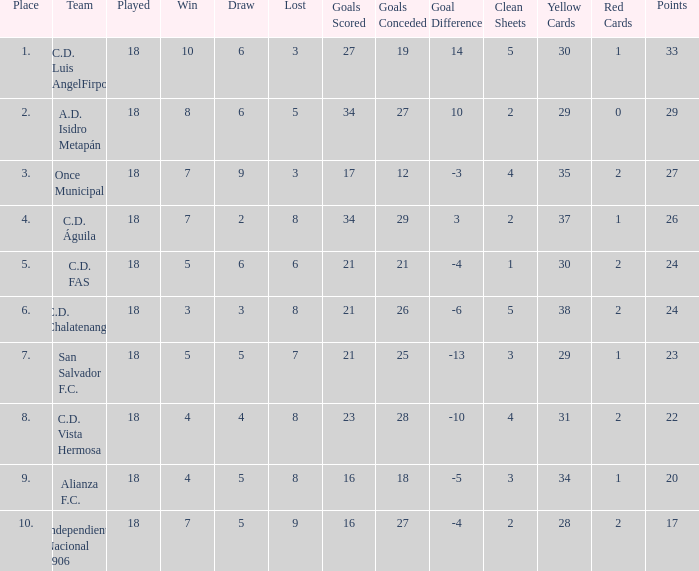Parse the full table. {'header': ['Place', 'Team', 'Played', 'Win', 'Draw', 'Lost', 'Goals Scored', 'Goals Conceded', 'Goal Difference', 'Clean Sheets', 'Yellow Cards', 'Red Cards', 'Points'], 'rows': [['1.', 'C.D. Luis AngelFirpo', '18', '10', '6', '3', '27', '19', '14', '5', '30', '1', '33'], ['2.', 'A.D. Isidro Metapán', '18', '8', '6', '5', '34', '27', '10', '2', '29', '0', '29'], ['3.', 'Once Municipal', '18', '7', '9', '3', '17', '12', '-3', '4', '35', '2', '27'], ['4.', 'C.D. Águila', '18', '7', '2', '8', '34', '29', '3', '2', '37', '1', '26'], ['5.', 'C.D. FAS', '18', '5', '6', '6', '21', '21', '-4', '1', '30', '2', '24'], ['6.', 'C.D. Chalatenango', '18', '3', '3', '8', '21', '26', '-6', '5', '38', '2', '24'], ['7.', 'San Salvador F.C.', '18', '5', '5', '7', '21', '25', '-13', '3', '29', '1', '23'], ['8.', 'C.D. Vista Hermosa', '18', '4', '4', '8', '23', '28', '-10', '4', '31', '2', '22'], ['9.', 'Alianza F.C.', '18', '4', '5', '8', '16', '18', '-5', '3', '34', '1', '20'], ['10.', 'Independiente Nacional 1906', '18', '7', '5', '9', '16', '27', '-4', '2', '28', '2', '17']]} How many points were in a game that had a lost of 5, greater than place 2, and 27 goals conceded? 0.0. 